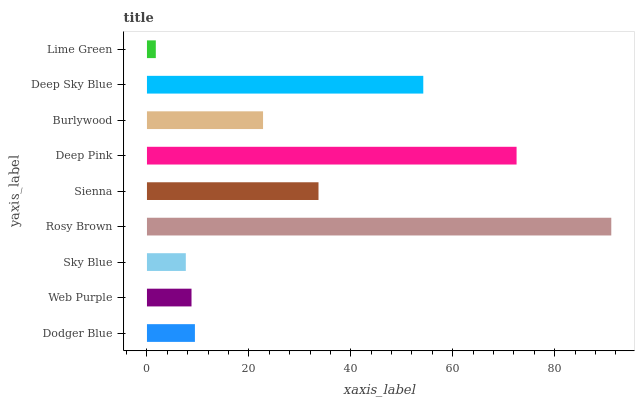Is Lime Green the minimum?
Answer yes or no. Yes. Is Rosy Brown the maximum?
Answer yes or no. Yes. Is Web Purple the minimum?
Answer yes or no. No. Is Web Purple the maximum?
Answer yes or no. No. Is Dodger Blue greater than Web Purple?
Answer yes or no. Yes. Is Web Purple less than Dodger Blue?
Answer yes or no. Yes. Is Web Purple greater than Dodger Blue?
Answer yes or no. No. Is Dodger Blue less than Web Purple?
Answer yes or no. No. Is Burlywood the high median?
Answer yes or no. Yes. Is Burlywood the low median?
Answer yes or no. Yes. Is Dodger Blue the high median?
Answer yes or no. No. Is Rosy Brown the low median?
Answer yes or no. No. 